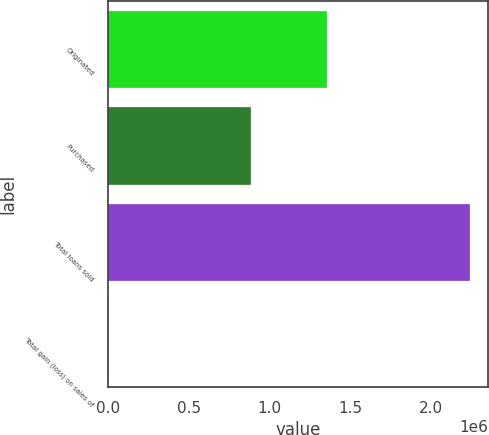Convert chart to OTSL. <chart><loc_0><loc_0><loc_500><loc_500><bar_chart><fcel>Originated<fcel>Purchased<fcel>Total loans sold<fcel>Total gain (loss) on sales of<nl><fcel>1.35452e+06<fcel>885026<fcel>2.23955e+06<fcel>3914<nl></chart> 